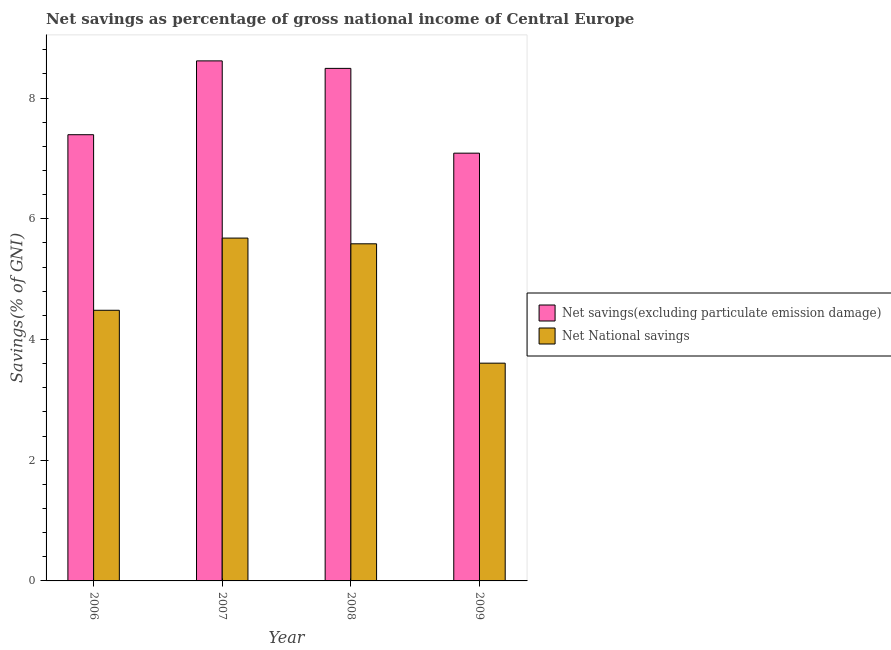How many groups of bars are there?
Make the answer very short. 4. How many bars are there on the 2nd tick from the left?
Provide a succinct answer. 2. How many bars are there on the 1st tick from the right?
Your answer should be very brief. 2. In how many cases, is the number of bars for a given year not equal to the number of legend labels?
Your answer should be very brief. 0. What is the net savings(excluding particulate emission damage) in 2007?
Provide a succinct answer. 8.62. Across all years, what is the maximum net national savings?
Ensure brevity in your answer.  5.68. Across all years, what is the minimum net savings(excluding particulate emission damage)?
Give a very brief answer. 7.09. In which year was the net savings(excluding particulate emission damage) minimum?
Ensure brevity in your answer.  2009. What is the total net national savings in the graph?
Make the answer very short. 19.36. What is the difference between the net national savings in 2006 and that in 2007?
Your answer should be compact. -1.2. What is the difference between the net savings(excluding particulate emission damage) in 2009 and the net national savings in 2006?
Keep it short and to the point. -0.31. What is the average net national savings per year?
Your answer should be very brief. 4.84. In how many years, is the net national savings greater than 4.8 %?
Ensure brevity in your answer.  2. What is the ratio of the net savings(excluding particulate emission damage) in 2007 to that in 2008?
Make the answer very short. 1.01. What is the difference between the highest and the second highest net savings(excluding particulate emission damage)?
Your answer should be compact. 0.12. What is the difference between the highest and the lowest net national savings?
Offer a terse response. 2.07. What does the 1st bar from the left in 2008 represents?
Keep it short and to the point. Net savings(excluding particulate emission damage). What does the 1st bar from the right in 2008 represents?
Your response must be concise. Net National savings. How many bars are there?
Keep it short and to the point. 8. Are all the bars in the graph horizontal?
Offer a very short reply. No. How many years are there in the graph?
Provide a succinct answer. 4. What is the difference between two consecutive major ticks on the Y-axis?
Ensure brevity in your answer.  2. Are the values on the major ticks of Y-axis written in scientific E-notation?
Your response must be concise. No. Does the graph contain any zero values?
Provide a short and direct response. No. What is the title of the graph?
Offer a terse response. Net savings as percentage of gross national income of Central Europe. Does "Fertility rate" appear as one of the legend labels in the graph?
Provide a short and direct response. No. What is the label or title of the Y-axis?
Your response must be concise. Savings(% of GNI). What is the Savings(% of GNI) in Net savings(excluding particulate emission damage) in 2006?
Your answer should be compact. 7.39. What is the Savings(% of GNI) of Net National savings in 2006?
Ensure brevity in your answer.  4.48. What is the Savings(% of GNI) in Net savings(excluding particulate emission damage) in 2007?
Your response must be concise. 8.62. What is the Savings(% of GNI) in Net National savings in 2007?
Ensure brevity in your answer.  5.68. What is the Savings(% of GNI) of Net savings(excluding particulate emission damage) in 2008?
Offer a very short reply. 8.49. What is the Savings(% of GNI) of Net National savings in 2008?
Keep it short and to the point. 5.59. What is the Savings(% of GNI) of Net savings(excluding particulate emission damage) in 2009?
Provide a succinct answer. 7.09. What is the Savings(% of GNI) of Net National savings in 2009?
Your answer should be compact. 3.61. Across all years, what is the maximum Savings(% of GNI) of Net savings(excluding particulate emission damage)?
Your answer should be very brief. 8.62. Across all years, what is the maximum Savings(% of GNI) in Net National savings?
Offer a very short reply. 5.68. Across all years, what is the minimum Savings(% of GNI) of Net savings(excluding particulate emission damage)?
Provide a succinct answer. 7.09. Across all years, what is the minimum Savings(% of GNI) of Net National savings?
Make the answer very short. 3.61. What is the total Savings(% of GNI) in Net savings(excluding particulate emission damage) in the graph?
Your answer should be compact. 31.59. What is the total Savings(% of GNI) of Net National savings in the graph?
Ensure brevity in your answer.  19.36. What is the difference between the Savings(% of GNI) of Net savings(excluding particulate emission damage) in 2006 and that in 2007?
Offer a terse response. -1.22. What is the difference between the Savings(% of GNI) in Net National savings in 2006 and that in 2007?
Offer a very short reply. -1.2. What is the difference between the Savings(% of GNI) in Net savings(excluding particulate emission damage) in 2006 and that in 2008?
Offer a terse response. -1.1. What is the difference between the Savings(% of GNI) in Net National savings in 2006 and that in 2008?
Keep it short and to the point. -1.1. What is the difference between the Savings(% of GNI) in Net savings(excluding particulate emission damage) in 2006 and that in 2009?
Your answer should be very brief. 0.31. What is the difference between the Savings(% of GNI) in Net National savings in 2006 and that in 2009?
Provide a short and direct response. 0.88. What is the difference between the Savings(% of GNI) in Net savings(excluding particulate emission damage) in 2007 and that in 2008?
Ensure brevity in your answer.  0.12. What is the difference between the Savings(% of GNI) of Net National savings in 2007 and that in 2008?
Your response must be concise. 0.09. What is the difference between the Savings(% of GNI) of Net savings(excluding particulate emission damage) in 2007 and that in 2009?
Your answer should be very brief. 1.53. What is the difference between the Savings(% of GNI) of Net National savings in 2007 and that in 2009?
Provide a short and direct response. 2.07. What is the difference between the Savings(% of GNI) in Net savings(excluding particulate emission damage) in 2008 and that in 2009?
Ensure brevity in your answer.  1.4. What is the difference between the Savings(% of GNI) of Net National savings in 2008 and that in 2009?
Your response must be concise. 1.98. What is the difference between the Savings(% of GNI) of Net savings(excluding particulate emission damage) in 2006 and the Savings(% of GNI) of Net National savings in 2007?
Your answer should be very brief. 1.71. What is the difference between the Savings(% of GNI) of Net savings(excluding particulate emission damage) in 2006 and the Savings(% of GNI) of Net National savings in 2008?
Provide a short and direct response. 1.81. What is the difference between the Savings(% of GNI) in Net savings(excluding particulate emission damage) in 2006 and the Savings(% of GNI) in Net National savings in 2009?
Your answer should be very brief. 3.79. What is the difference between the Savings(% of GNI) in Net savings(excluding particulate emission damage) in 2007 and the Savings(% of GNI) in Net National savings in 2008?
Ensure brevity in your answer.  3.03. What is the difference between the Savings(% of GNI) in Net savings(excluding particulate emission damage) in 2007 and the Savings(% of GNI) in Net National savings in 2009?
Provide a short and direct response. 5.01. What is the difference between the Savings(% of GNI) of Net savings(excluding particulate emission damage) in 2008 and the Savings(% of GNI) of Net National savings in 2009?
Provide a short and direct response. 4.88. What is the average Savings(% of GNI) in Net savings(excluding particulate emission damage) per year?
Make the answer very short. 7.9. What is the average Savings(% of GNI) of Net National savings per year?
Your answer should be very brief. 4.84. In the year 2006, what is the difference between the Savings(% of GNI) in Net savings(excluding particulate emission damage) and Savings(% of GNI) in Net National savings?
Your response must be concise. 2.91. In the year 2007, what is the difference between the Savings(% of GNI) in Net savings(excluding particulate emission damage) and Savings(% of GNI) in Net National savings?
Give a very brief answer. 2.94. In the year 2008, what is the difference between the Savings(% of GNI) of Net savings(excluding particulate emission damage) and Savings(% of GNI) of Net National savings?
Provide a succinct answer. 2.91. In the year 2009, what is the difference between the Savings(% of GNI) of Net savings(excluding particulate emission damage) and Savings(% of GNI) of Net National savings?
Your answer should be very brief. 3.48. What is the ratio of the Savings(% of GNI) in Net savings(excluding particulate emission damage) in 2006 to that in 2007?
Your answer should be compact. 0.86. What is the ratio of the Savings(% of GNI) in Net National savings in 2006 to that in 2007?
Your response must be concise. 0.79. What is the ratio of the Savings(% of GNI) of Net savings(excluding particulate emission damage) in 2006 to that in 2008?
Offer a very short reply. 0.87. What is the ratio of the Savings(% of GNI) in Net National savings in 2006 to that in 2008?
Offer a terse response. 0.8. What is the ratio of the Savings(% of GNI) of Net savings(excluding particulate emission damage) in 2006 to that in 2009?
Provide a short and direct response. 1.04. What is the ratio of the Savings(% of GNI) of Net National savings in 2006 to that in 2009?
Offer a very short reply. 1.24. What is the ratio of the Savings(% of GNI) of Net savings(excluding particulate emission damage) in 2007 to that in 2008?
Provide a succinct answer. 1.01. What is the ratio of the Savings(% of GNI) in Net savings(excluding particulate emission damage) in 2007 to that in 2009?
Your response must be concise. 1.22. What is the ratio of the Savings(% of GNI) in Net National savings in 2007 to that in 2009?
Give a very brief answer. 1.57. What is the ratio of the Savings(% of GNI) of Net savings(excluding particulate emission damage) in 2008 to that in 2009?
Your answer should be very brief. 1.2. What is the ratio of the Savings(% of GNI) in Net National savings in 2008 to that in 2009?
Give a very brief answer. 1.55. What is the difference between the highest and the second highest Savings(% of GNI) of Net savings(excluding particulate emission damage)?
Make the answer very short. 0.12. What is the difference between the highest and the second highest Savings(% of GNI) in Net National savings?
Give a very brief answer. 0.09. What is the difference between the highest and the lowest Savings(% of GNI) in Net savings(excluding particulate emission damage)?
Offer a very short reply. 1.53. What is the difference between the highest and the lowest Savings(% of GNI) of Net National savings?
Provide a succinct answer. 2.07. 